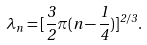Convert formula to latex. <formula><loc_0><loc_0><loc_500><loc_500>\lambda _ { n } = [ \frac { 3 } { 2 } \pi ( n - \frac { 1 } { 4 } ) ] ^ { 2 / 3 } .</formula> 